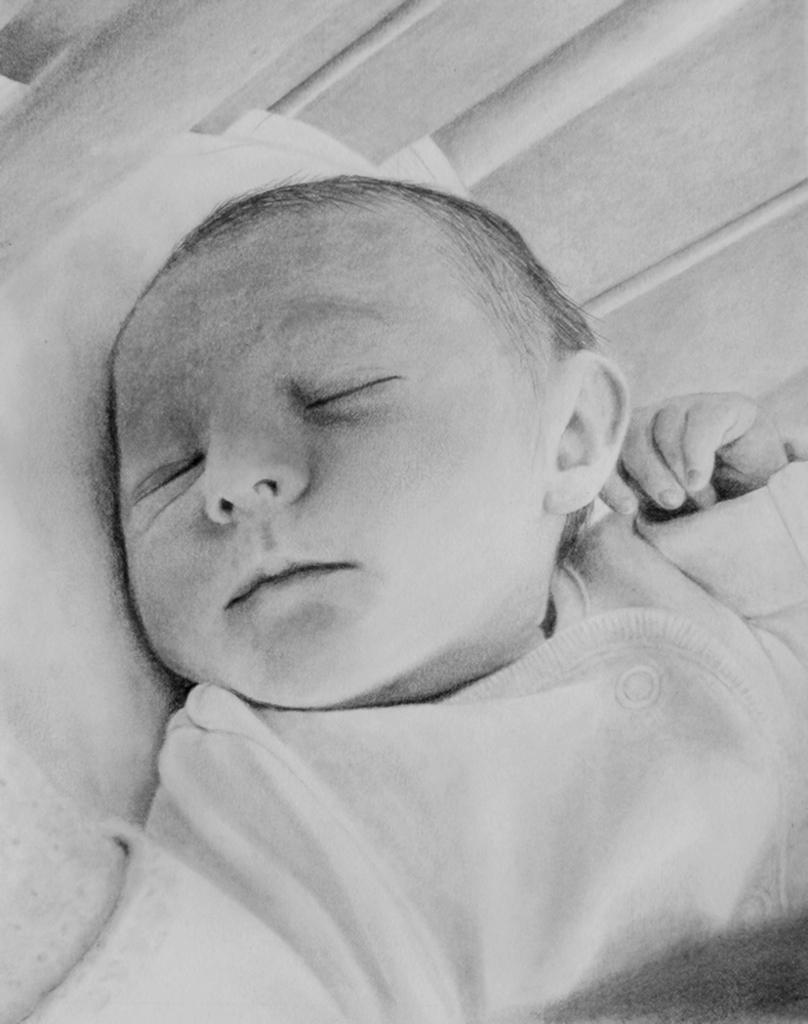What is the main subject of the picture? The main subject of the picture is a baby. What is the baby doing in the picture? The baby is sleeping in the picture. What is the color scheme of the picture? The picture is black and white. What type of building can be seen in the background of the picture? There is no building visible in the picture, as it is a black and white image of a sleeping baby. What store is the baby shopping at in the picture? There is no store present in the picture; it is a close-up image of a sleeping baby. 